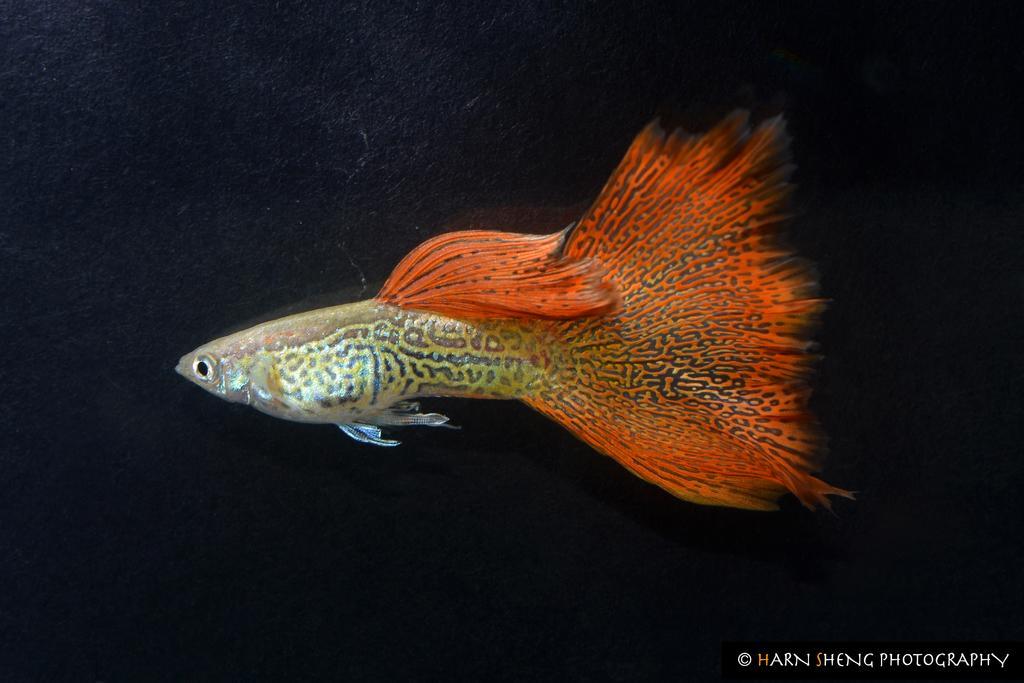Could you give a brief overview of what you see in this image? In this picture, we can see a fish, dark background, we can see some text on bottom right corner. 